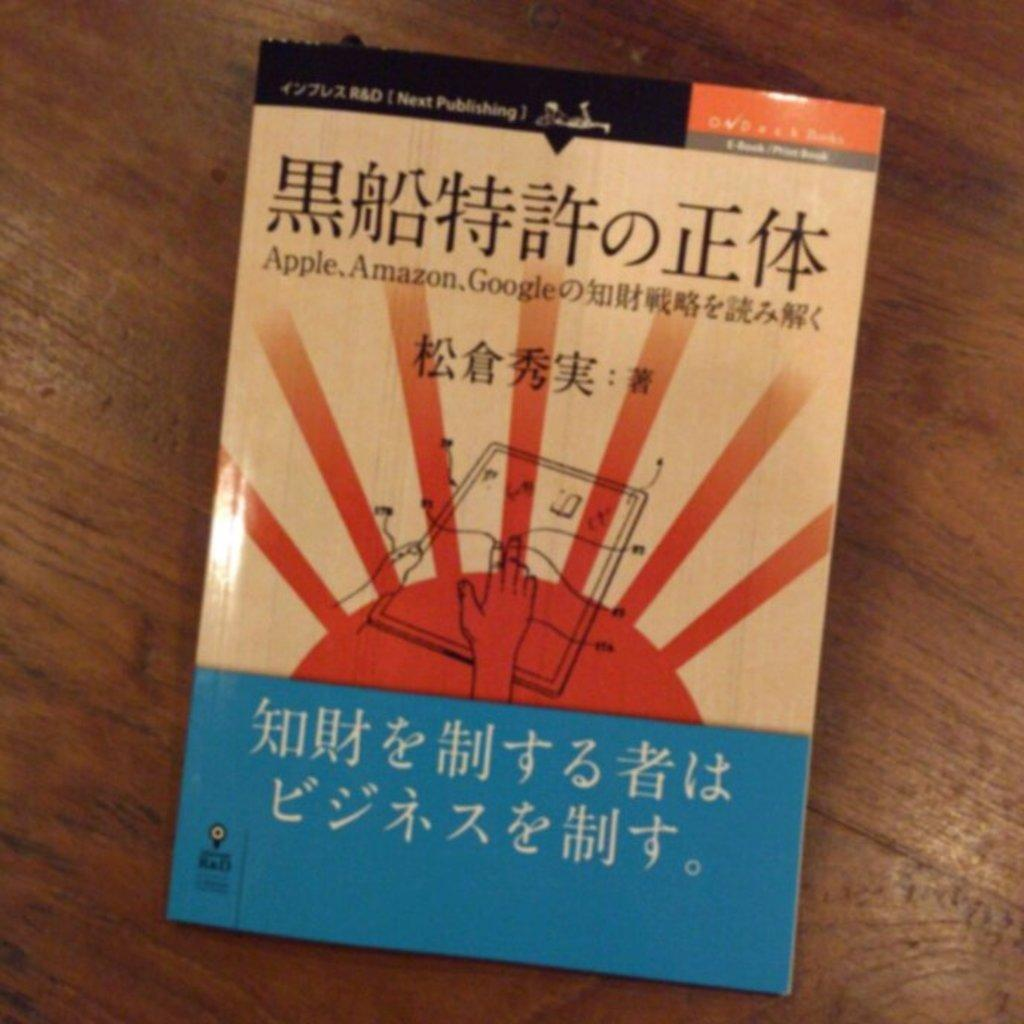<image>
Create a compact narrative representing the image presented. A blue and tan book with Mandarin written on the cover. 